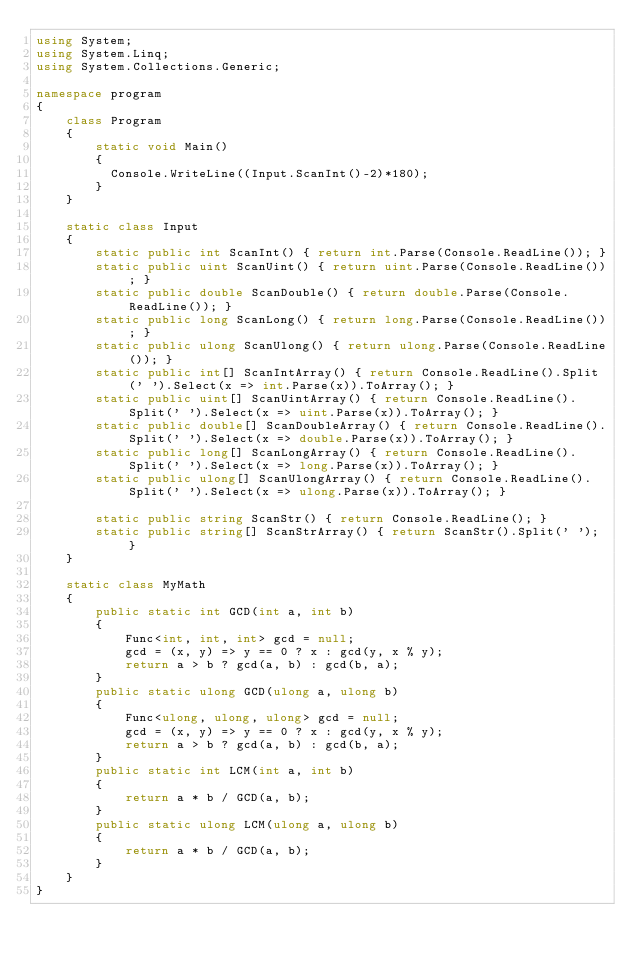Convert code to text. <code><loc_0><loc_0><loc_500><loc_500><_C#_>using System;
using System.Linq;
using System.Collections.Generic;

namespace program
{
    class Program
    {
        static void Main()
        {
          Console.WriteLine((Input.ScanInt()-2)*180);
        }
    }

    static class Input
    {
        static public int ScanInt() { return int.Parse(Console.ReadLine()); }
        static public uint ScanUint() { return uint.Parse(Console.ReadLine()); }
        static public double ScanDouble() { return double.Parse(Console.ReadLine()); }
        static public long ScanLong() { return long.Parse(Console.ReadLine()); }
        static public ulong ScanUlong() { return ulong.Parse(Console.ReadLine()); }
        static public int[] ScanIntArray() { return Console.ReadLine().Split(' ').Select(x => int.Parse(x)).ToArray(); }
        static public uint[] ScanUintArray() { return Console.ReadLine().Split(' ').Select(x => uint.Parse(x)).ToArray(); }
        static public double[] ScanDoubleArray() { return Console.ReadLine().Split(' ').Select(x => double.Parse(x)).ToArray(); }
        static public long[] ScanLongArray() { return Console.ReadLine().Split(' ').Select(x => long.Parse(x)).ToArray(); }
        static public ulong[] ScanUlongArray() { return Console.ReadLine().Split(' ').Select(x => ulong.Parse(x)).ToArray(); }

        static public string ScanStr() { return Console.ReadLine(); }
        static public string[] ScanStrArray() { return ScanStr().Split(' '); }
    }

    static class MyMath
    {
        public static int GCD(int a, int b)
        {
            Func<int, int, int> gcd = null;
            gcd = (x, y) => y == 0 ? x : gcd(y, x % y);
            return a > b ? gcd(a, b) : gcd(b, a);
        }
        public static ulong GCD(ulong a, ulong b)
        {
            Func<ulong, ulong, ulong> gcd = null;
            gcd = (x, y) => y == 0 ? x : gcd(y, x % y);
            return a > b ? gcd(a, b) : gcd(b, a);
        }
        public static int LCM(int a, int b)
        {
            return a * b / GCD(a, b);
        }
        public static ulong LCM(ulong a, ulong b)
        {
            return a * b / GCD(a, b);
        }
    }
}
</code> 